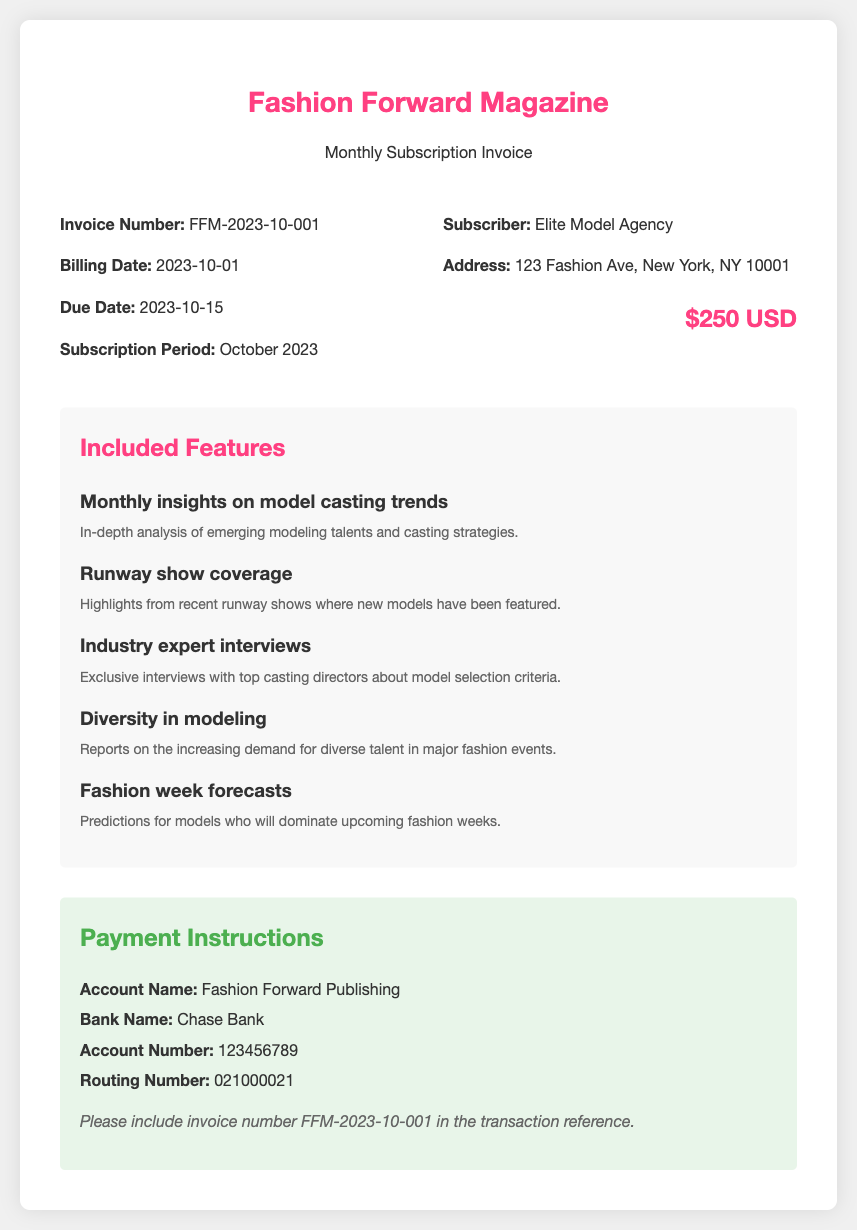What is the invoice number? The invoice number is listed under the invoice details section, which is FFM-2023-10-001.
Answer: FFM-2023-10-001 What is the billing date? The billing date is mentioned in the invoice details, showing when the invoice was generated.
Answer: 2023-10-01 Who is the subscriber? The subscriber's name is provided in the invoice details, indicating to whom the invoice is addressed.
Answer: Elite Model Agency What is included in the subscription fee? The subscription fee is explicitly stated in the document under the subscriber details.
Answer: $250 USD Which feature focuses on model selection criteria? The feature that discusses model selection criteria can be found in the list of included features in the document.
Answer: Industry expert interviews How many features are listed in the document? The number of features can be counted from the "Included Features" section of the invoice.
Answer: 5 What does the diversity feature report on? The diversity feature specifically addresses trends and demands related to model representation in the industry.
Answer: Increasing demand for diverse talent When is the due date for the subscription payment? The due date is specified in the invoice details section indicating when payment is required.
Answer: 2023-10-15 What bank is the payment account with? The bank where the account is held is mentioned in the payment instructions part of the document.
Answer: Chase Bank 